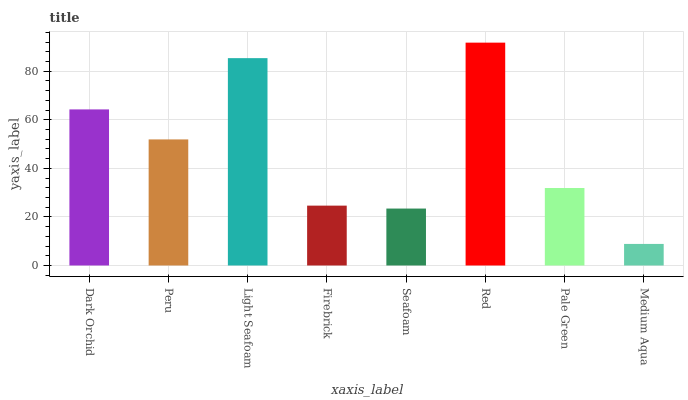Is Medium Aqua the minimum?
Answer yes or no. Yes. Is Red the maximum?
Answer yes or no. Yes. Is Peru the minimum?
Answer yes or no. No. Is Peru the maximum?
Answer yes or no. No. Is Dark Orchid greater than Peru?
Answer yes or no. Yes. Is Peru less than Dark Orchid?
Answer yes or no. Yes. Is Peru greater than Dark Orchid?
Answer yes or no. No. Is Dark Orchid less than Peru?
Answer yes or no. No. Is Peru the high median?
Answer yes or no. Yes. Is Pale Green the low median?
Answer yes or no. Yes. Is Medium Aqua the high median?
Answer yes or no. No. Is Light Seafoam the low median?
Answer yes or no. No. 